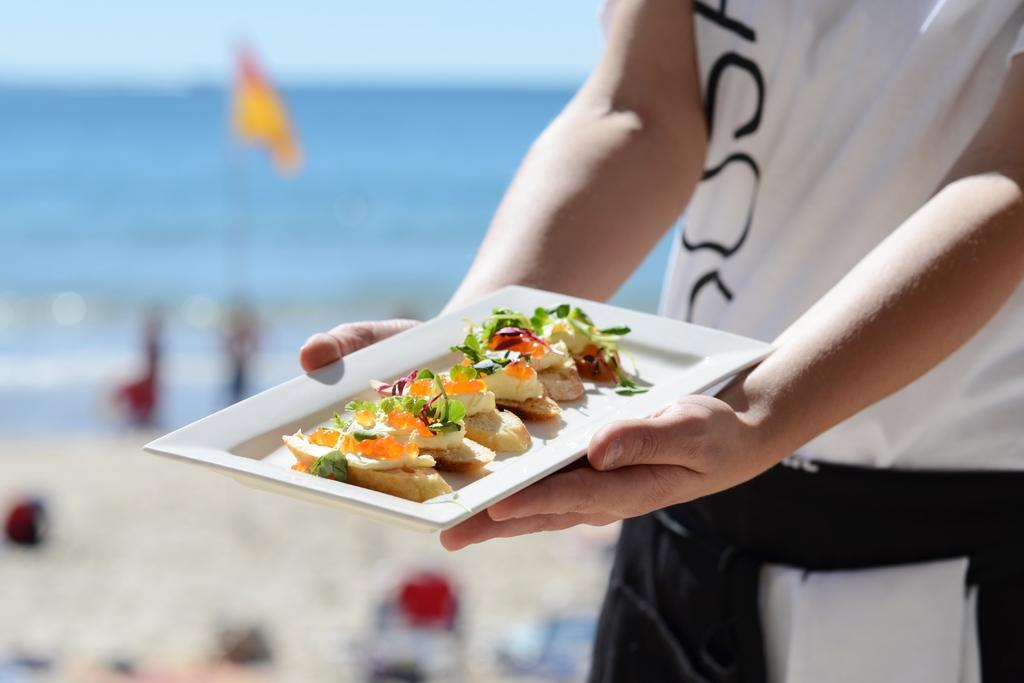What is the man doing on the right side of the image? The man is standing on the right side of the image. What is the man holding in his hand? The man is holding a plate in his hand. What is on the plate that the man is holding? There is food on the plate. What can be seen in the distance behind the man? There is a sea visible in the background of the image. What type of berry can be seen growing on the railway tracks in the image? There is no railway or berry present in the image; it features a man holding a plate with food on it and a sea in the background. 